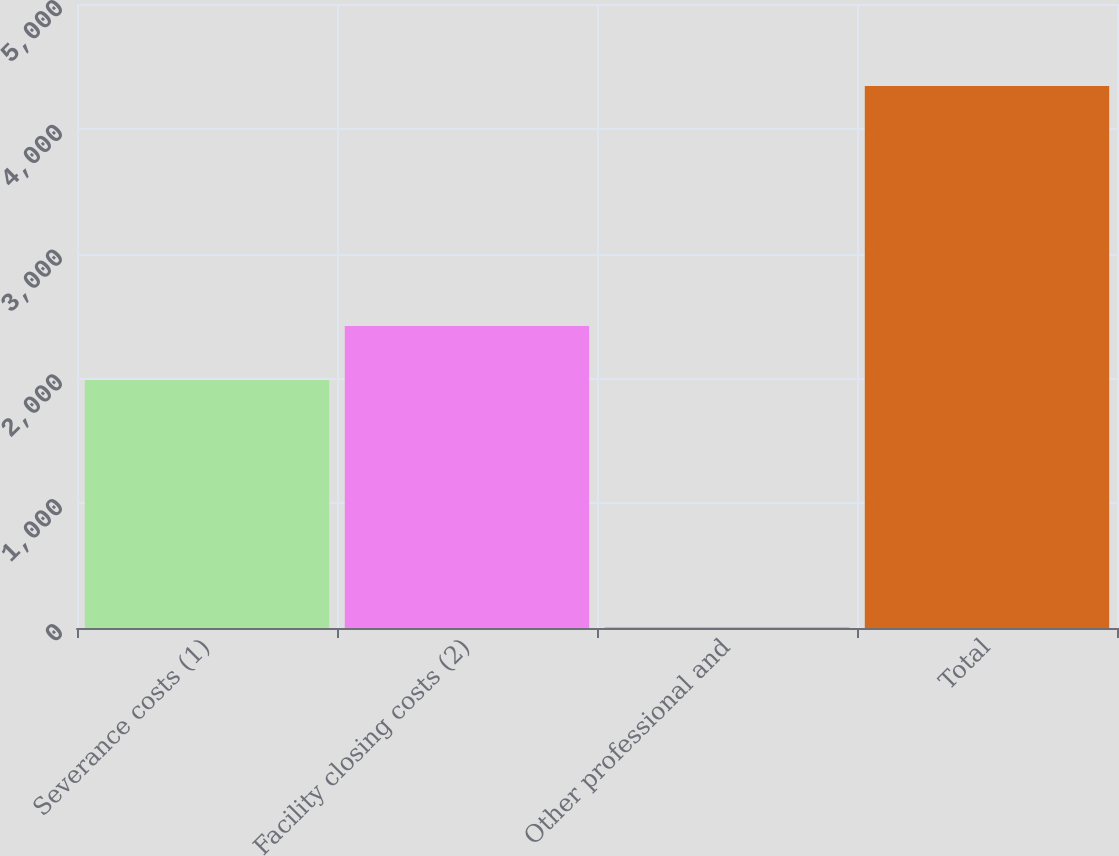Convert chart to OTSL. <chart><loc_0><loc_0><loc_500><loc_500><bar_chart><fcel>Severance costs (1)<fcel>Facility closing costs (2)<fcel>Other professional and<fcel>Total<nl><fcel>1987<fcel>2420.8<fcel>5<fcel>4343<nl></chart> 